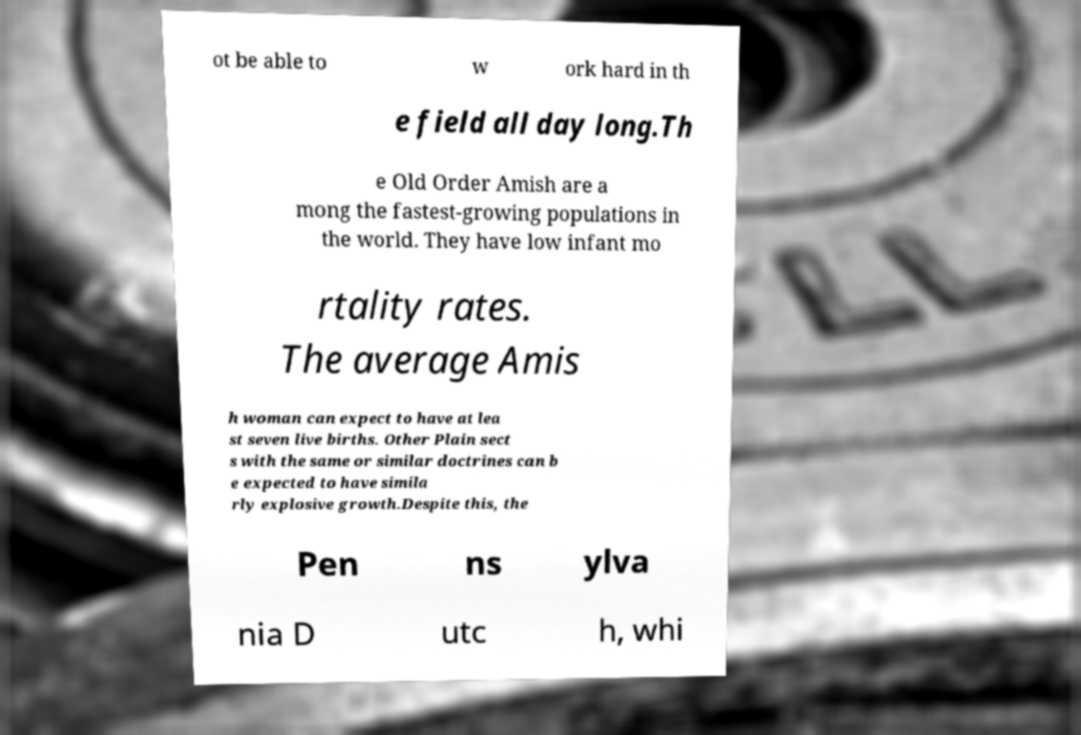For documentation purposes, I need the text within this image transcribed. Could you provide that? ot be able to w ork hard in th e field all day long.Th e Old Order Amish are a mong the fastest-growing populations in the world. They have low infant mo rtality rates. The average Amis h woman can expect to have at lea st seven live births. Other Plain sect s with the same or similar doctrines can b e expected to have simila rly explosive growth.Despite this, the Pen ns ylva nia D utc h, whi 